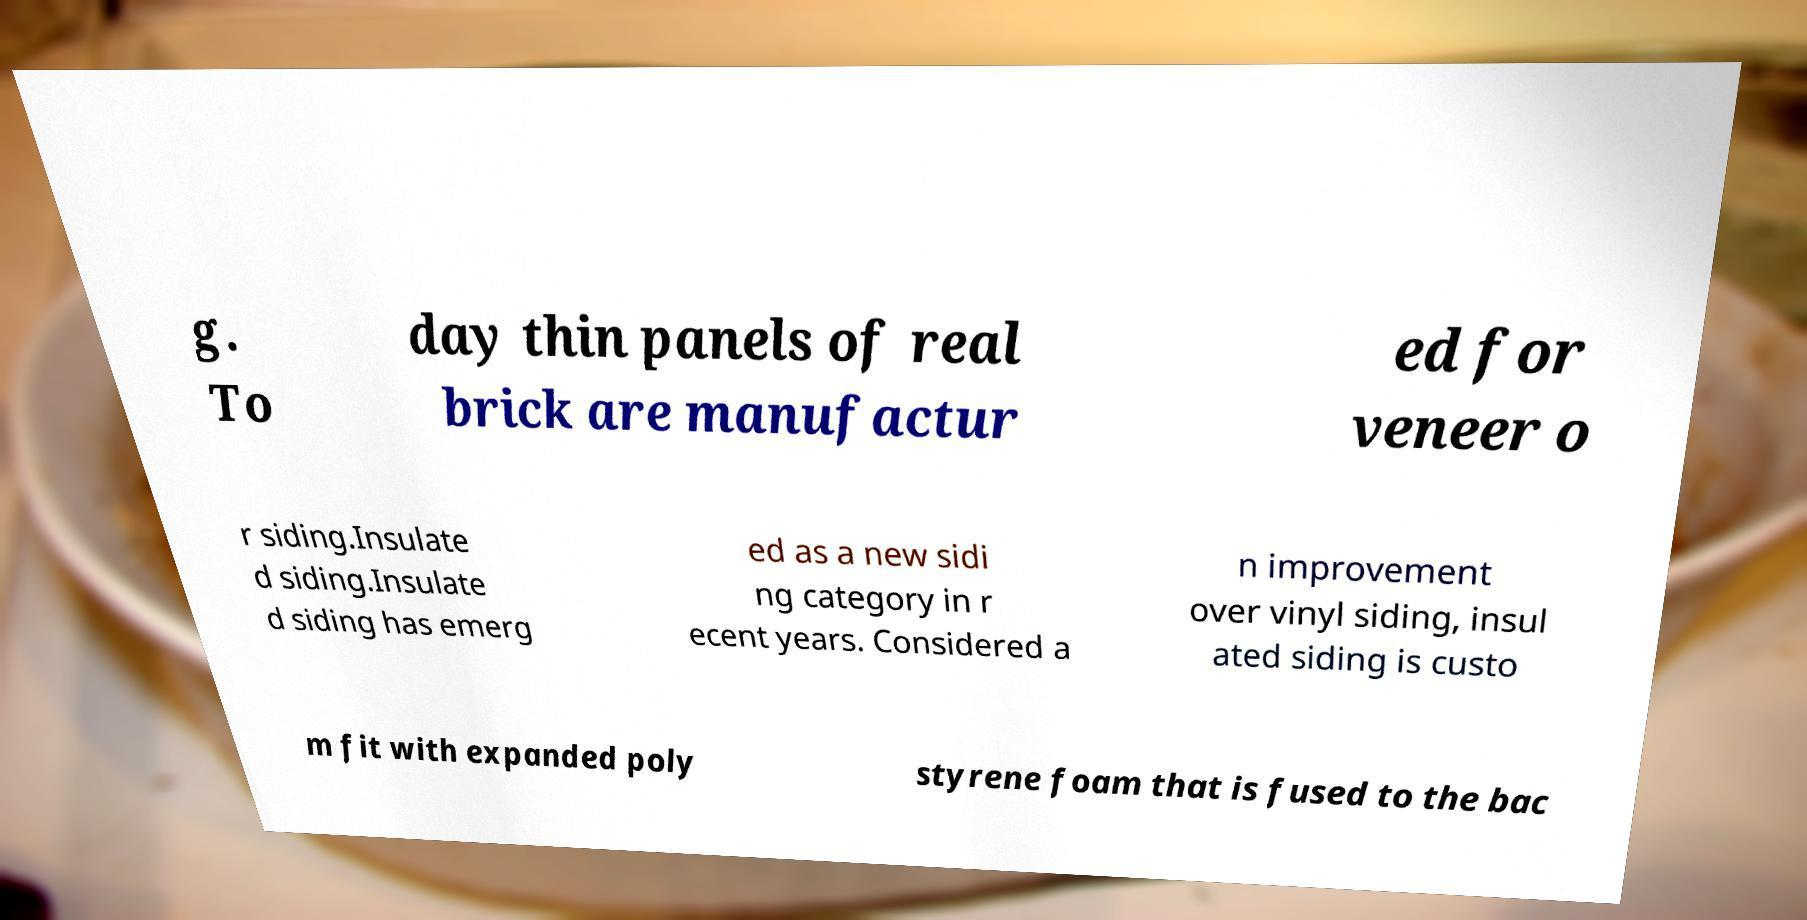Could you assist in decoding the text presented in this image and type it out clearly? g. To day thin panels of real brick are manufactur ed for veneer o r siding.Insulate d siding.Insulate d siding has emerg ed as a new sidi ng category in r ecent years. Considered a n improvement over vinyl siding, insul ated siding is custo m fit with expanded poly styrene foam that is fused to the bac 